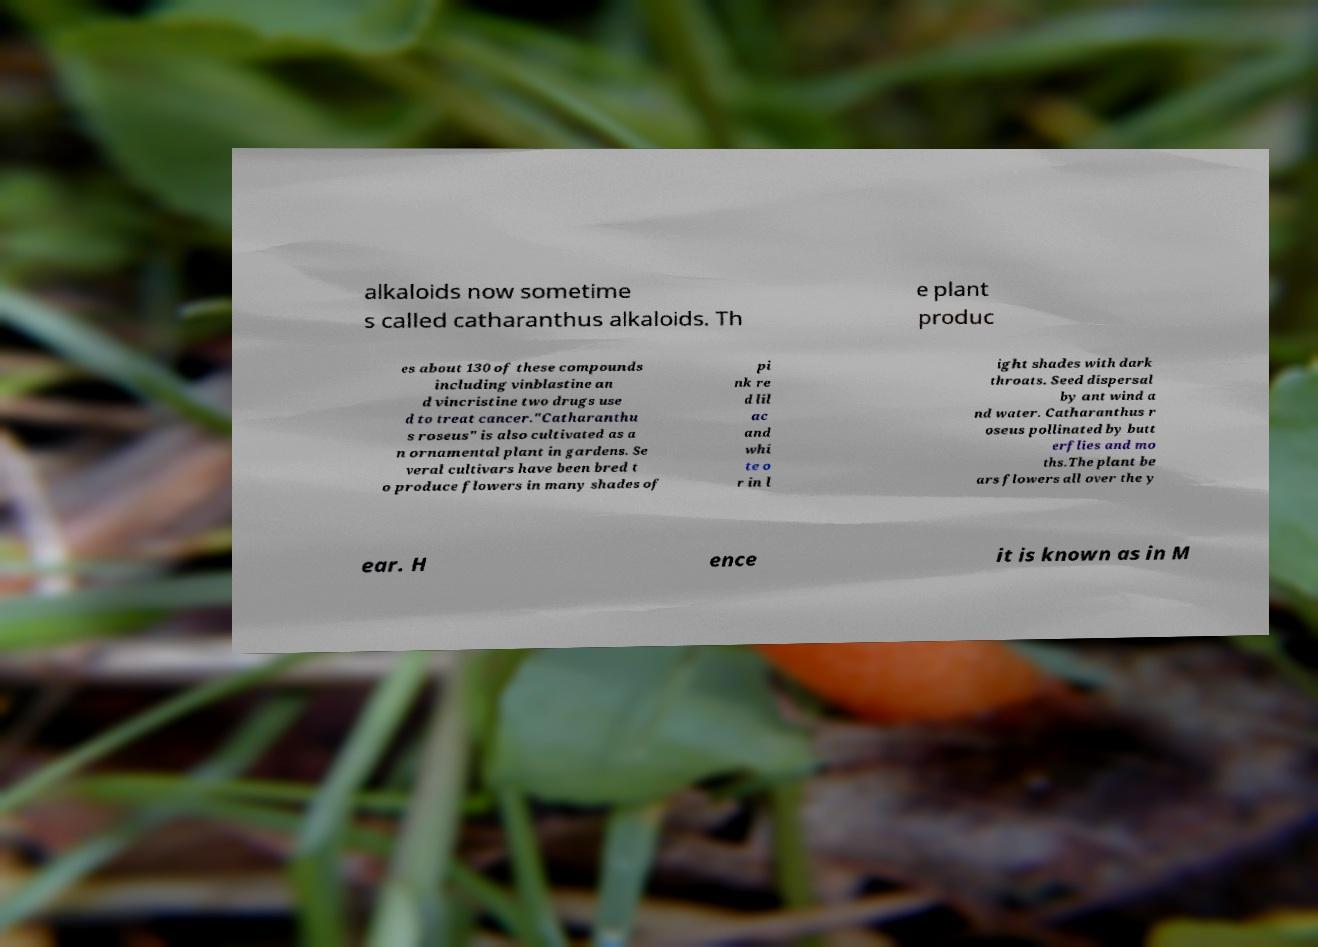Can you accurately transcribe the text from the provided image for me? alkaloids now sometime s called catharanthus alkaloids. Th e plant produc es about 130 of these compounds including vinblastine an d vincristine two drugs use d to treat cancer."Catharanthu s roseus" is also cultivated as a n ornamental plant in gardens. Se veral cultivars have been bred t o produce flowers in many shades of pi nk re d lil ac and whi te o r in l ight shades with dark throats. Seed dispersal by ant wind a nd water. Catharanthus r oseus pollinated by butt erflies and mo ths.The plant be ars flowers all over the y ear. H ence it is known as in M 